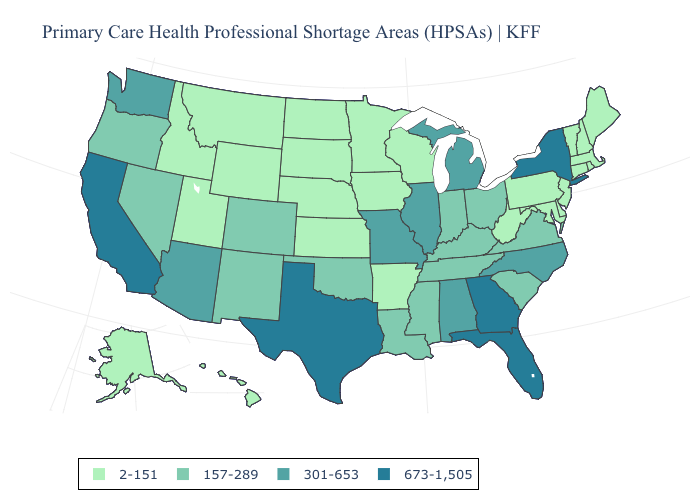Which states have the highest value in the USA?
Write a very short answer. California, Florida, Georgia, New York, Texas. What is the value of California?
Answer briefly. 673-1,505. What is the value of Illinois?
Give a very brief answer. 301-653. Name the states that have a value in the range 2-151?
Answer briefly. Alaska, Arkansas, Connecticut, Delaware, Hawaii, Idaho, Iowa, Kansas, Maine, Maryland, Massachusetts, Minnesota, Montana, Nebraska, New Hampshire, New Jersey, North Dakota, Pennsylvania, Rhode Island, South Dakota, Utah, Vermont, West Virginia, Wisconsin, Wyoming. Does New Hampshire have the lowest value in the Northeast?
Short answer required. Yes. What is the lowest value in the USA?
Keep it brief. 2-151. What is the highest value in states that border Idaho?
Answer briefly. 301-653. Among the states that border Oklahoma , does New Mexico have the highest value?
Answer briefly. No. Does the map have missing data?
Give a very brief answer. No. Does California have a lower value than Rhode Island?
Give a very brief answer. No. Does California have the highest value in the West?
Concise answer only. Yes. What is the value of Virginia?
Keep it brief. 157-289. Is the legend a continuous bar?
Concise answer only. No. Which states have the highest value in the USA?
Keep it brief. California, Florida, Georgia, New York, Texas. Does Massachusetts have a lower value than New Jersey?
Give a very brief answer. No. 